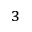<formula> <loc_0><loc_0><loc_500><loc_500>_ { 3 }</formula> 